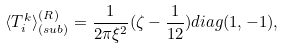Convert formula to latex. <formula><loc_0><loc_0><loc_500><loc_500>\langle T _ { i } ^ { k } \rangle _ { ( s u b ) } ^ { ( R ) } = \frac { 1 } { 2 \pi \xi ^ { 2 } } ( \zeta - \frac { 1 } { 1 2 } ) d i a g ( 1 , - 1 ) ,</formula> 